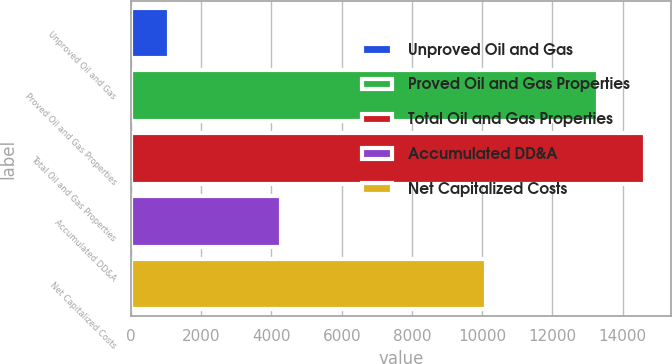<chart> <loc_0><loc_0><loc_500><loc_500><bar_chart><fcel>Unproved Oil and Gas<fcel>Proved Oil and Gas Properties<fcel>Total Oil and Gas Properties<fcel>Accumulated DD&A<fcel>Net Capitalized Costs<nl><fcel>1081<fcel>13312<fcel>14643.2<fcel>4270<fcel>10123<nl></chart> 